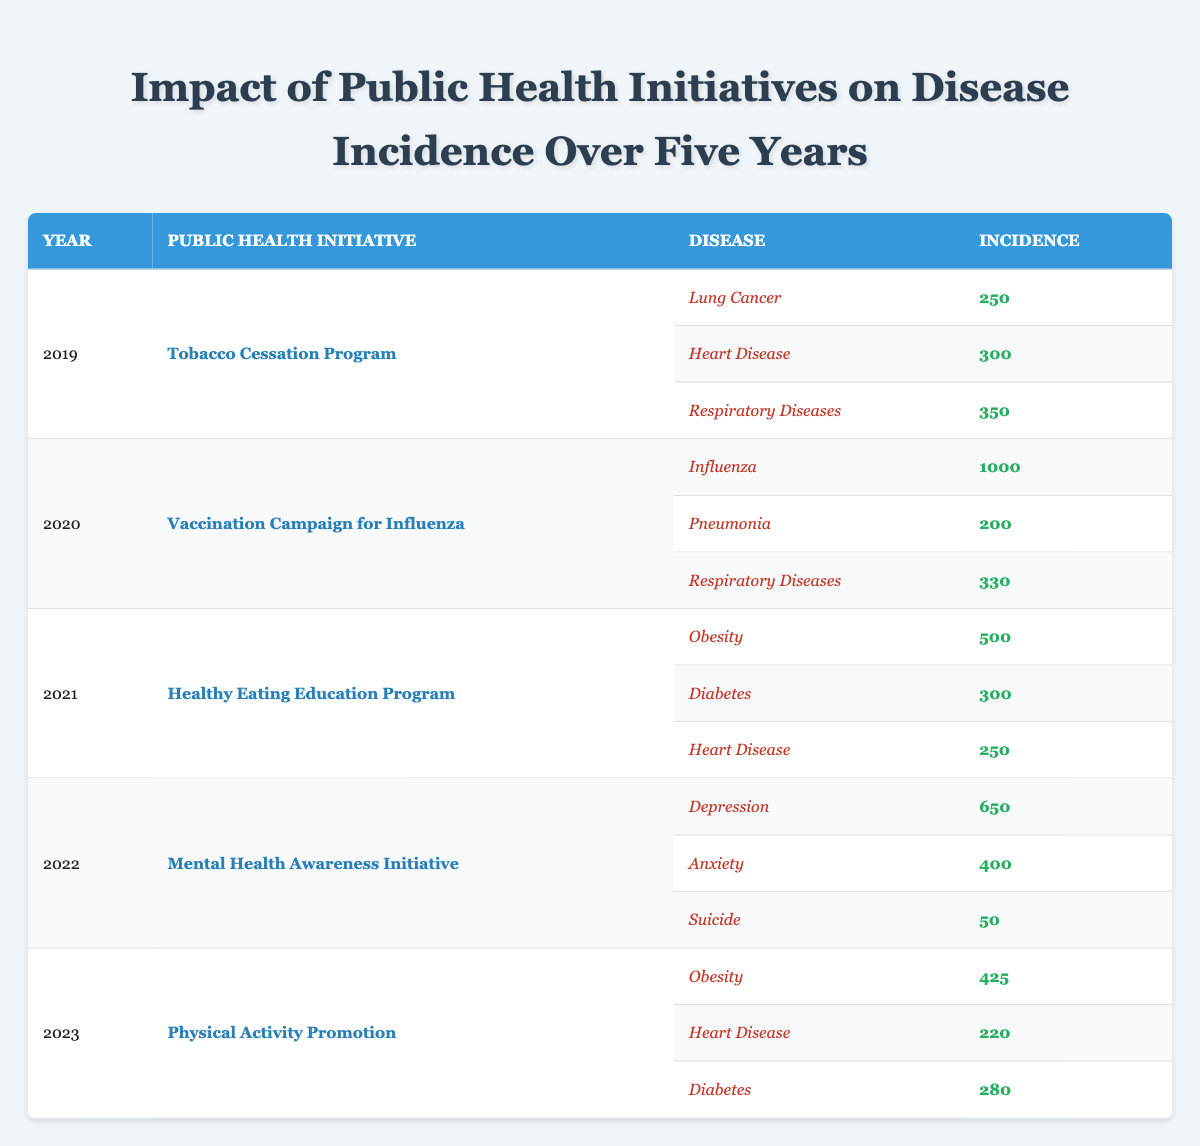What was the initiative implemented in 2019? According to the table, the public health initiative for the year 2019 was the Tobacco Cessation Program. It is explicitly stated in the corresponding row for that year.
Answer: Tobacco Cessation Program Which disease had the highest incidence in 2020? From the table, in 2020, the incidence data shows Influenza at 1000 cases, which is the highest among the listed diseases for that year. The other diseases, pneumonia and respiratory diseases, had incidences of 200 and 330, respectively.
Answer: Influenza What is the total incidence of heart disease across the years in the table? The table indicates that heart disease incidences are as follows: 300 in 2019, 250 in 2021, and 220 in 2023. To find the total, we sum these values: 300 + 250 + 220 = 770.
Answer: 770 Was there a decrease in the incidence of obesity from 2021 to 2023? The table shows that the incidence of obesity was 500 in 2021 and decreased to 425 in 2023. Therefore, the incidence did decrease over this period.
Answer: Yes What is the average incidence of respiratory diseases over the five years? In the table, the incidences for respiratory diseases are: 350 in 2019, 330 in 2020, and there are no data for 2021, 2022, and 2023. Thus, the average is calculated by dividing the sum of the available data (350 + 330 = 680) by the number of data points (2), resulting in 680/2 = 340.
Answer: 340 Which year had the highest incidence of depression? The table shows that in 2022, the incidence of depression was recorded at 650 cases, which is higher than the incidences recorded for any other year or disease.
Answer: 2022 What was the incidence of diabetes in 2021? The incidence of diabetes as specified in the table for the year 2021 was 300. This is found directly in the row for the Healthy Eating Education Program.
Answer: 300 How does the incidence of suicide in 2022 compare to heart disease in 2021? The incidence of suicide in 2022 was 50, and the incidence of heart disease in 2021 was 250. To compare, we see that 50 is significantly lower than 250, indicating a notable difference between these two figures.
Answer: Lower 